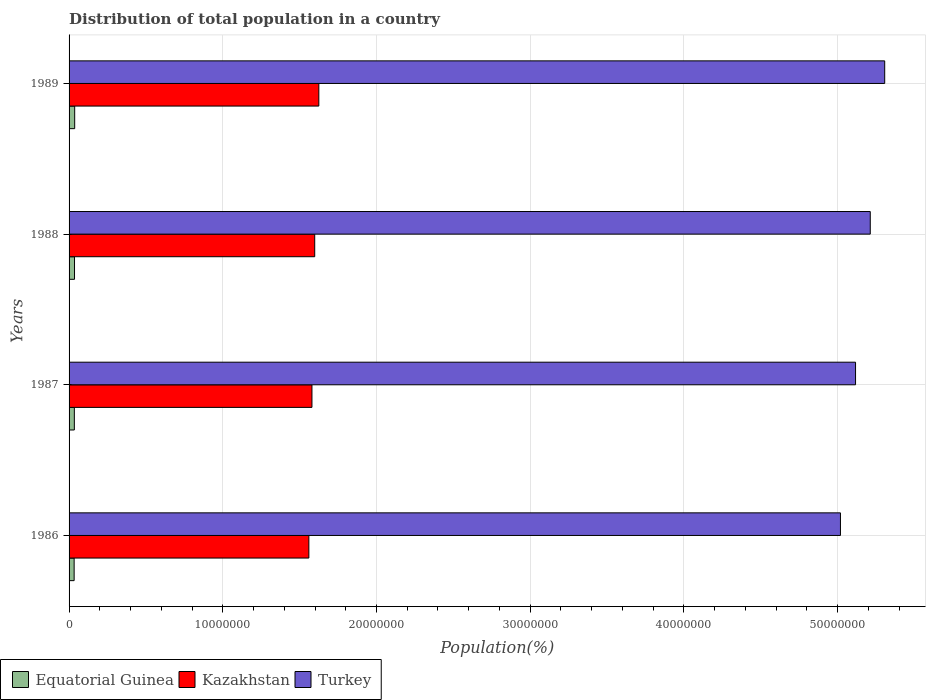How many groups of bars are there?
Keep it short and to the point. 4. Are the number of bars per tick equal to the number of legend labels?
Offer a very short reply. Yes. Are the number of bars on each tick of the Y-axis equal?
Provide a short and direct response. Yes. How many bars are there on the 3rd tick from the top?
Make the answer very short. 3. What is the population of in Kazakhstan in 1986?
Your answer should be compact. 1.56e+07. Across all years, what is the maximum population of in Turkey?
Keep it short and to the point. 5.31e+07. Across all years, what is the minimum population of in Turkey?
Your response must be concise. 5.02e+07. What is the total population of in Turkey in the graph?
Keep it short and to the point. 2.07e+08. What is the difference between the population of in Equatorial Guinea in 1988 and that in 1989?
Provide a short and direct response. -1.10e+04. What is the difference between the population of in Turkey in 1988 and the population of in Equatorial Guinea in 1986?
Your response must be concise. 5.18e+07. What is the average population of in Equatorial Guinea per year?
Your answer should be very brief. 3.48e+05. In the year 1987, what is the difference between the population of in Equatorial Guinea and population of in Turkey?
Offer a terse response. -5.08e+07. In how many years, is the population of in Equatorial Guinea greater than 50000000 %?
Keep it short and to the point. 0. What is the ratio of the population of in Kazakhstan in 1987 to that in 1988?
Give a very brief answer. 0.99. Is the difference between the population of in Equatorial Guinea in 1988 and 1989 greater than the difference between the population of in Turkey in 1988 and 1989?
Give a very brief answer. Yes. What is the difference between the highest and the second highest population of in Equatorial Guinea?
Your answer should be compact. 1.10e+04. What is the difference between the highest and the lowest population of in Turkey?
Ensure brevity in your answer.  2.88e+06. What does the 2nd bar from the top in 1989 represents?
Your answer should be very brief. Kazakhstan. What does the 2nd bar from the bottom in 1986 represents?
Your response must be concise. Kazakhstan. Is it the case that in every year, the sum of the population of in Kazakhstan and population of in Turkey is greater than the population of in Equatorial Guinea?
Your response must be concise. Yes. How many bars are there?
Provide a short and direct response. 12. Are all the bars in the graph horizontal?
Make the answer very short. Yes. How many years are there in the graph?
Your answer should be compact. 4. What is the difference between two consecutive major ticks on the X-axis?
Provide a succinct answer. 1.00e+07. Are the values on the major ticks of X-axis written in scientific E-notation?
Give a very brief answer. No. Where does the legend appear in the graph?
Provide a short and direct response. Bottom left. How many legend labels are there?
Your answer should be compact. 3. How are the legend labels stacked?
Make the answer very short. Horizontal. What is the title of the graph?
Your answer should be very brief. Distribution of total population in a country. Does "Bosnia and Herzegovina" appear as one of the legend labels in the graph?
Keep it short and to the point. No. What is the label or title of the X-axis?
Offer a very short reply. Population(%). What is the label or title of the Y-axis?
Your response must be concise. Years. What is the Population(%) of Equatorial Guinea in 1986?
Your answer should be very brief. 3.30e+05. What is the Population(%) of Kazakhstan in 1986?
Keep it short and to the point. 1.56e+07. What is the Population(%) of Turkey in 1986?
Your answer should be very brief. 5.02e+07. What is the Population(%) of Equatorial Guinea in 1987?
Ensure brevity in your answer.  3.43e+05. What is the Population(%) of Kazakhstan in 1987?
Your response must be concise. 1.58e+07. What is the Population(%) of Turkey in 1987?
Offer a very short reply. 5.12e+07. What is the Population(%) in Equatorial Guinea in 1988?
Offer a very short reply. 3.54e+05. What is the Population(%) of Kazakhstan in 1988?
Provide a succinct answer. 1.60e+07. What is the Population(%) in Turkey in 1988?
Provide a short and direct response. 5.21e+07. What is the Population(%) of Equatorial Guinea in 1989?
Offer a terse response. 3.65e+05. What is the Population(%) in Kazakhstan in 1989?
Your response must be concise. 1.62e+07. What is the Population(%) of Turkey in 1989?
Your answer should be very brief. 5.31e+07. Across all years, what is the maximum Population(%) in Equatorial Guinea?
Your response must be concise. 3.65e+05. Across all years, what is the maximum Population(%) of Kazakhstan?
Ensure brevity in your answer.  1.62e+07. Across all years, what is the maximum Population(%) of Turkey?
Offer a very short reply. 5.31e+07. Across all years, what is the minimum Population(%) in Equatorial Guinea?
Provide a short and direct response. 3.30e+05. Across all years, what is the minimum Population(%) in Kazakhstan?
Give a very brief answer. 1.56e+07. Across all years, what is the minimum Population(%) in Turkey?
Provide a short and direct response. 5.02e+07. What is the total Population(%) in Equatorial Guinea in the graph?
Ensure brevity in your answer.  1.39e+06. What is the total Population(%) in Kazakhstan in the graph?
Keep it short and to the point. 6.36e+07. What is the total Population(%) in Turkey in the graph?
Ensure brevity in your answer.  2.07e+08. What is the difference between the Population(%) in Equatorial Guinea in 1986 and that in 1987?
Your answer should be compact. -1.30e+04. What is the difference between the Population(%) in Kazakhstan in 1986 and that in 1987?
Your answer should be very brief. -2.01e+05. What is the difference between the Population(%) in Turkey in 1986 and that in 1987?
Your response must be concise. -9.82e+05. What is the difference between the Population(%) in Equatorial Guinea in 1986 and that in 1988?
Provide a succinct answer. -2.42e+04. What is the difference between the Population(%) in Kazakhstan in 1986 and that in 1988?
Your response must be concise. -3.82e+05. What is the difference between the Population(%) of Turkey in 1986 and that in 1988?
Your response must be concise. -1.94e+06. What is the difference between the Population(%) in Equatorial Guinea in 1986 and that in 1989?
Provide a succinct answer. -3.52e+04. What is the difference between the Population(%) of Kazakhstan in 1986 and that in 1989?
Your response must be concise. -6.49e+05. What is the difference between the Population(%) of Turkey in 1986 and that in 1989?
Ensure brevity in your answer.  -2.88e+06. What is the difference between the Population(%) in Equatorial Guinea in 1987 and that in 1988?
Your answer should be compact. -1.12e+04. What is the difference between the Population(%) in Kazakhstan in 1987 and that in 1988?
Provide a succinct answer. -1.81e+05. What is the difference between the Population(%) of Turkey in 1987 and that in 1988?
Ensure brevity in your answer.  -9.58e+05. What is the difference between the Population(%) of Equatorial Guinea in 1987 and that in 1989?
Offer a very short reply. -2.22e+04. What is the difference between the Population(%) of Kazakhstan in 1987 and that in 1989?
Ensure brevity in your answer.  -4.48e+05. What is the difference between the Population(%) of Turkey in 1987 and that in 1989?
Provide a short and direct response. -1.90e+06. What is the difference between the Population(%) of Equatorial Guinea in 1988 and that in 1989?
Offer a very short reply. -1.10e+04. What is the difference between the Population(%) in Kazakhstan in 1988 and that in 1989?
Ensure brevity in your answer.  -2.67e+05. What is the difference between the Population(%) in Turkey in 1988 and that in 1989?
Keep it short and to the point. -9.40e+05. What is the difference between the Population(%) in Equatorial Guinea in 1986 and the Population(%) in Kazakhstan in 1987?
Make the answer very short. -1.55e+07. What is the difference between the Population(%) of Equatorial Guinea in 1986 and the Population(%) of Turkey in 1987?
Offer a very short reply. -5.08e+07. What is the difference between the Population(%) in Kazakhstan in 1986 and the Population(%) in Turkey in 1987?
Offer a terse response. -3.56e+07. What is the difference between the Population(%) in Equatorial Guinea in 1986 and the Population(%) in Kazakhstan in 1988?
Give a very brief answer. -1.57e+07. What is the difference between the Population(%) of Equatorial Guinea in 1986 and the Population(%) of Turkey in 1988?
Your answer should be very brief. -5.18e+07. What is the difference between the Population(%) of Kazakhstan in 1986 and the Population(%) of Turkey in 1988?
Your answer should be very brief. -3.65e+07. What is the difference between the Population(%) in Equatorial Guinea in 1986 and the Population(%) in Kazakhstan in 1989?
Your response must be concise. -1.59e+07. What is the difference between the Population(%) of Equatorial Guinea in 1986 and the Population(%) of Turkey in 1989?
Offer a terse response. -5.27e+07. What is the difference between the Population(%) in Kazakhstan in 1986 and the Population(%) in Turkey in 1989?
Your answer should be compact. -3.75e+07. What is the difference between the Population(%) of Equatorial Guinea in 1987 and the Population(%) of Kazakhstan in 1988?
Provide a short and direct response. -1.56e+07. What is the difference between the Population(%) of Equatorial Guinea in 1987 and the Population(%) of Turkey in 1988?
Make the answer very short. -5.18e+07. What is the difference between the Population(%) in Kazakhstan in 1987 and the Population(%) in Turkey in 1988?
Offer a terse response. -3.63e+07. What is the difference between the Population(%) of Equatorial Guinea in 1987 and the Population(%) of Kazakhstan in 1989?
Offer a very short reply. -1.59e+07. What is the difference between the Population(%) of Equatorial Guinea in 1987 and the Population(%) of Turkey in 1989?
Give a very brief answer. -5.27e+07. What is the difference between the Population(%) of Kazakhstan in 1987 and the Population(%) of Turkey in 1989?
Provide a short and direct response. -3.73e+07. What is the difference between the Population(%) in Equatorial Guinea in 1988 and the Population(%) in Kazakhstan in 1989?
Offer a terse response. -1.59e+07. What is the difference between the Population(%) of Equatorial Guinea in 1988 and the Population(%) of Turkey in 1989?
Offer a very short reply. -5.27e+07. What is the difference between the Population(%) in Kazakhstan in 1988 and the Population(%) in Turkey in 1989?
Make the answer very short. -3.71e+07. What is the average Population(%) in Equatorial Guinea per year?
Keep it short and to the point. 3.48e+05. What is the average Population(%) in Kazakhstan per year?
Offer a very short reply. 1.59e+07. What is the average Population(%) in Turkey per year?
Offer a very short reply. 5.16e+07. In the year 1986, what is the difference between the Population(%) in Equatorial Guinea and Population(%) in Kazakhstan?
Make the answer very short. -1.53e+07. In the year 1986, what is the difference between the Population(%) in Equatorial Guinea and Population(%) in Turkey?
Offer a terse response. -4.99e+07. In the year 1986, what is the difference between the Population(%) in Kazakhstan and Population(%) in Turkey?
Your answer should be very brief. -3.46e+07. In the year 1987, what is the difference between the Population(%) of Equatorial Guinea and Population(%) of Kazakhstan?
Your response must be concise. -1.55e+07. In the year 1987, what is the difference between the Population(%) in Equatorial Guinea and Population(%) in Turkey?
Offer a terse response. -5.08e+07. In the year 1987, what is the difference between the Population(%) of Kazakhstan and Population(%) of Turkey?
Make the answer very short. -3.54e+07. In the year 1988, what is the difference between the Population(%) in Equatorial Guinea and Population(%) in Kazakhstan?
Offer a terse response. -1.56e+07. In the year 1988, what is the difference between the Population(%) of Equatorial Guinea and Population(%) of Turkey?
Your response must be concise. -5.18e+07. In the year 1988, what is the difference between the Population(%) of Kazakhstan and Population(%) of Turkey?
Make the answer very short. -3.61e+07. In the year 1989, what is the difference between the Population(%) of Equatorial Guinea and Population(%) of Kazakhstan?
Provide a succinct answer. -1.59e+07. In the year 1989, what is the difference between the Population(%) of Equatorial Guinea and Population(%) of Turkey?
Offer a very short reply. -5.27e+07. In the year 1989, what is the difference between the Population(%) of Kazakhstan and Population(%) of Turkey?
Ensure brevity in your answer.  -3.68e+07. What is the ratio of the Population(%) in Equatorial Guinea in 1986 to that in 1987?
Make the answer very short. 0.96. What is the ratio of the Population(%) in Kazakhstan in 1986 to that in 1987?
Your answer should be compact. 0.99. What is the ratio of the Population(%) in Turkey in 1986 to that in 1987?
Your answer should be compact. 0.98. What is the ratio of the Population(%) in Equatorial Guinea in 1986 to that in 1988?
Keep it short and to the point. 0.93. What is the ratio of the Population(%) in Kazakhstan in 1986 to that in 1988?
Offer a very short reply. 0.98. What is the ratio of the Population(%) of Turkey in 1986 to that in 1988?
Give a very brief answer. 0.96. What is the ratio of the Population(%) of Equatorial Guinea in 1986 to that in 1989?
Offer a very short reply. 0.9. What is the ratio of the Population(%) in Kazakhstan in 1986 to that in 1989?
Keep it short and to the point. 0.96. What is the ratio of the Population(%) of Turkey in 1986 to that in 1989?
Give a very brief answer. 0.95. What is the ratio of the Population(%) of Equatorial Guinea in 1987 to that in 1988?
Offer a very short reply. 0.97. What is the ratio of the Population(%) in Kazakhstan in 1987 to that in 1988?
Make the answer very short. 0.99. What is the ratio of the Population(%) in Turkey in 1987 to that in 1988?
Ensure brevity in your answer.  0.98. What is the ratio of the Population(%) of Equatorial Guinea in 1987 to that in 1989?
Keep it short and to the point. 0.94. What is the ratio of the Population(%) in Kazakhstan in 1987 to that in 1989?
Your answer should be very brief. 0.97. What is the ratio of the Population(%) in Turkey in 1987 to that in 1989?
Give a very brief answer. 0.96. What is the ratio of the Population(%) in Kazakhstan in 1988 to that in 1989?
Provide a succinct answer. 0.98. What is the ratio of the Population(%) in Turkey in 1988 to that in 1989?
Your answer should be compact. 0.98. What is the difference between the highest and the second highest Population(%) of Equatorial Guinea?
Give a very brief answer. 1.10e+04. What is the difference between the highest and the second highest Population(%) of Kazakhstan?
Your answer should be compact. 2.67e+05. What is the difference between the highest and the second highest Population(%) of Turkey?
Your answer should be very brief. 9.40e+05. What is the difference between the highest and the lowest Population(%) of Equatorial Guinea?
Your response must be concise. 3.52e+04. What is the difference between the highest and the lowest Population(%) in Kazakhstan?
Your answer should be very brief. 6.49e+05. What is the difference between the highest and the lowest Population(%) in Turkey?
Offer a terse response. 2.88e+06. 